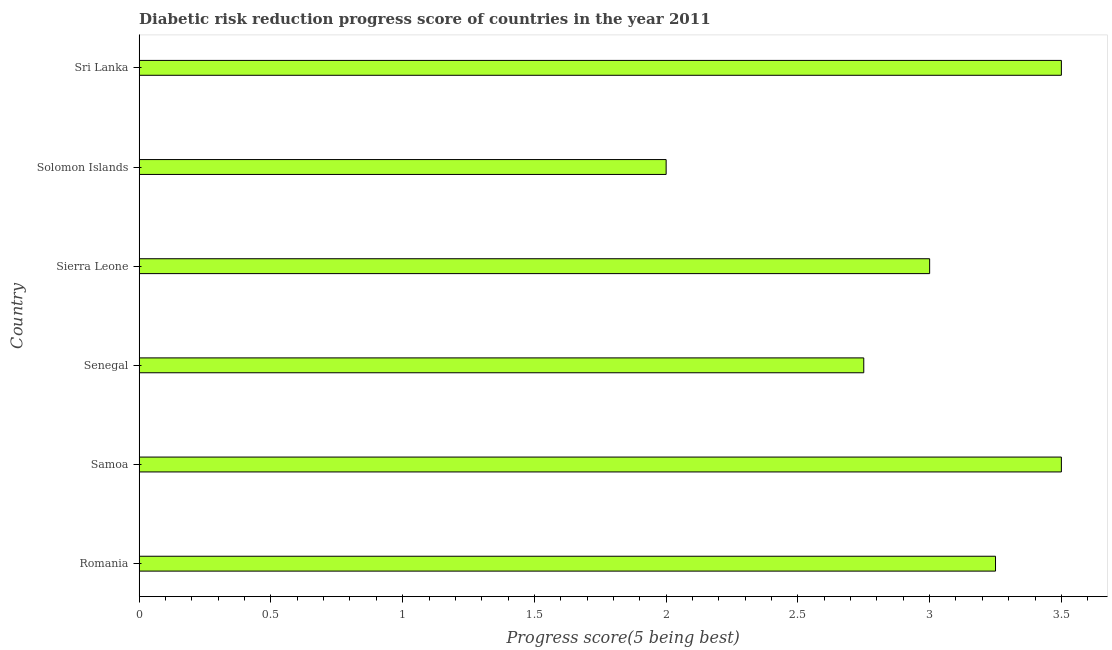Does the graph contain grids?
Make the answer very short. No. What is the title of the graph?
Make the answer very short. Diabetic risk reduction progress score of countries in the year 2011. What is the label or title of the X-axis?
Make the answer very short. Progress score(5 being best). What is the label or title of the Y-axis?
Offer a very short reply. Country. Across all countries, what is the minimum disaster risk reduction progress score?
Make the answer very short. 2. In which country was the disaster risk reduction progress score maximum?
Your answer should be very brief. Samoa. In which country was the disaster risk reduction progress score minimum?
Give a very brief answer. Solomon Islands. What is the sum of the disaster risk reduction progress score?
Keep it short and to the point. 18. What is the difference between the disaster risk reduction progress score in Senegal and Sierra Leone?
Ensure brevity in your answer.  -0.25. What is the median disaster risk reduction progress score?
Provide a short and direct response. 3.12. In how many countries, is the disaster risk reduction progress score greater than 0.1 ?
Provide a succinct answer. 6. What is the ratio of the disaster risk reduction progress score in Senegal to that in Sri Lanka?
Give a very brief answer. 0.79. Is the sum of the disaster risk reduction progress score in Senegal and Solomon Islands greater than the maximum disaster risk reduction progress score across all countries?
Give a very brief answer. Yes. Are all the bars in the graph horizontal?
Offer a terse response. Yes. How many countries are there in the graph?
Offer a very short reply. 6. Are the values on the major ticks of X-axis written in scientific E-notation?
Your answer should be very brief. No. What is the Progress score(5 being best) of Senegal?
Ensure brevity in your answer.  2.75. What is the Progress score(5 being best) in Sierra Leone?
Make the answer very short. 3. What is the Progress score(5 being best) of Sri Lanka?
Make the answer very short. 3.5. What is the difference between the Progress score(5 being best) in Romania and Solomon Islands?
Your answer should be very brief. 1.25. What is the difference between the Progress score(5 being best) in Senegal and Solomon Islands?
Make the answer very short. 0.75. What is the difference between the Progress score(5 being best) in Senegal and Sri Lanka?
Your answer should be very brief. -0.75. What is the difference between the Progress score(5 being best) in Solomon Islands and Sri Lanka?
Ensure brevity in your answer.  -1.5. What is the ratio of the Progress score(5 being best) in Romania to that in Samoa?
Your response must be concise. 0.93. What is the ratio of the Progress score(5 being best) in Romania to that in Senegal?
Offer a terse response. 1.18. What is the ratio of the Progress score(5 being best) in Romania to that in Sierra Leone?
Provide a succinct answer. 1.08. What is the ratio of the Progress score(5 being best) in Romania to that in Solomon Islands?
Give a very brief answer. 1.62. What is the ratio of the Progress score(5 being best) in Romania to that in Sri Lanka?
Your answer should be very brief. 0.93. What is the ratio of the Progress score(5 being best) in Samoa to that in Senegal?
Your answer should be compact. 1.27. What is the ratio of the Progress score(5 being best) in Samoa to that in Sierra Leone?
Provide a short and direct response. 1.17. What is the ratio of the Progress score(5 being best) in Samoa to that in Sri Lanka?
Your response must be concise. 1. What is the ratio of the Progress score(5 being best) in Senegal to that in Sierra Leone?
Your response must be concise. 0.92. What is the ratio of the Progress score(5 being best) in Senegal to that in Solomon Islands?
Keep it short and to the point. 1.38. What is the ratio of the Progress score(5 being best) in Senegal to that in Sri Lanka?
Your answer should be compact. 0.79. What is the ratio of the Progress score(5 being best) in Sierra Leone to that in Sri Lanka?
Your answer should be compact. 0.86. What is the ratio of the Progress score(5 being best) in Solomon Islands to that in Sri Lanka?
Make the answer very short. 0.57. 